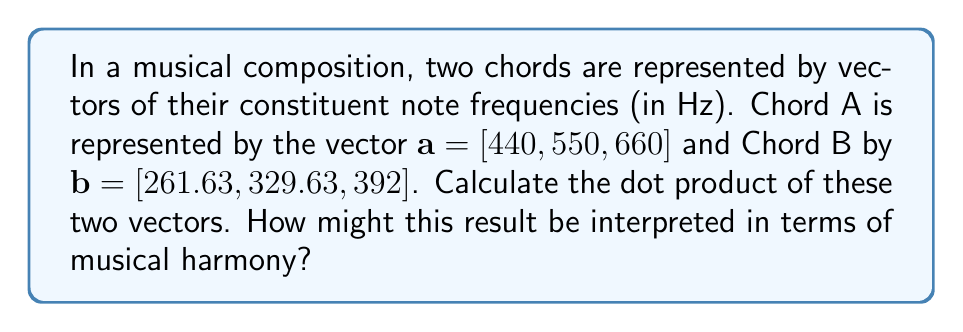Give your solution to this math problem. To calculate the dot product of two vectors, we multiply corresponding elements and sum the results. For vectors $\mathbf{a} = [a_1, a_2, a_3]$ and $\mathbf{b} = [b_1, b_2, b_3]$, the dot product is given by:

$$\mathbf{a} \cdot \mathbf{b} = a_1b_1 + a_2b_2 + a_3b_3$$

For the given vectors:

$\mathbf{a} = [440, 550, 660]$
$\mathbf{b} = [261.63, 329.63, 392]$

Let's calculate each term:

1. $a_1b_1 = 440 \times 261.63 = 115,117.2$
2. $a_2b_2 = 550 \times 329.63 = 181,296.5$
3. $a_3b_3 = 660 \times 392 = 258,720$

Now, sum these products:

$$\mathbf{a} \cdot \mathbf{b} = 115,117.2 + 181,296.5 + 258,720 = 555,133.7$$

Interpretation: The dot product of frequency vectors can be seen as a measure of harmonic relationship between chords. A larger dot product might indicate more harmonic consonance, while a smaller one might suggest more dissonance. However, this is a simplified interpretation and doesn't account for the complexities of musical theory and perception.

For a blind musician using braille sheet music, this mathematical representation could be translated into tactile notation, providing a unique way to analyze and understand harmonic relationships in music composition.
Answer: $555,133.7$ 